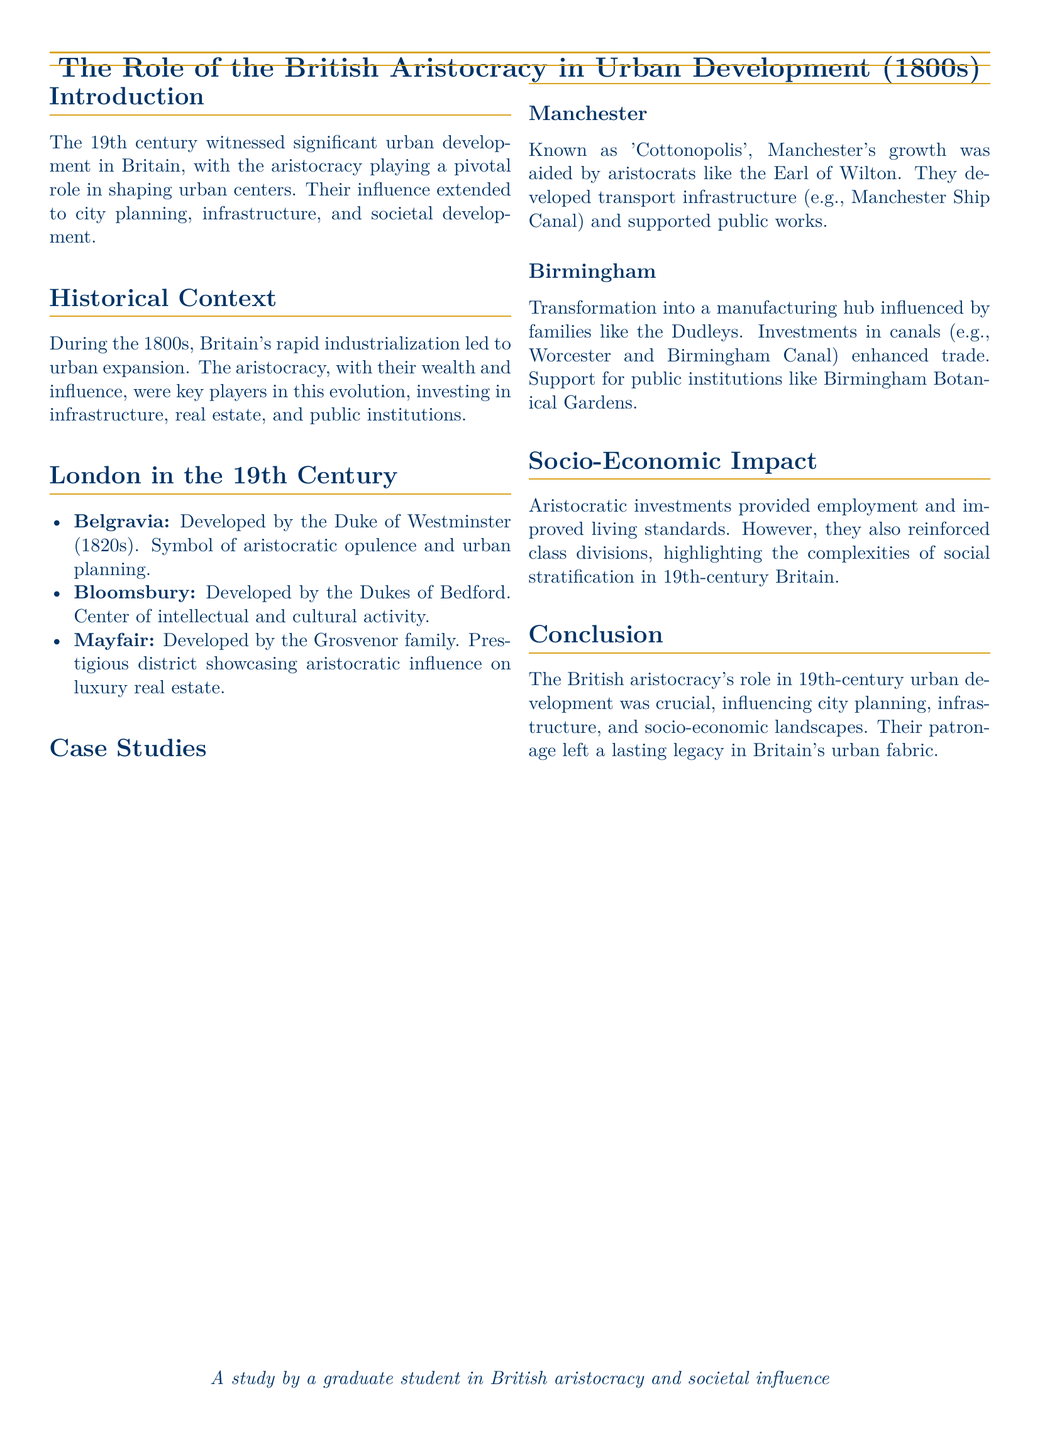what was the key player in urban development during the 1800s? The document states that the British aristocracy played a pivotal role in shaping urban centers.
Answer: British aristocracy who developed Belgravia? The Duke of Westminster developed Belgravia in the 1820s as a symbol of aristocratic opulence.
Answer: Duke of Westminster which city is referred to as 'Cottonopolis'? The document mentions Manchester as known by this nickname due to its cotton industry.
Answer: Manchester what major infrastructure did the Earl of Wilton contribute to in Manchester? The Earl of Wilton developed transport infrastructure like the Manchester Ship Canal.
Answer: Manchester Ship Canal who were the key figures in the development of Birmingham? The document highlights families like the Dudleys as influential in Birmingham's transformation.
Answer: Dudleys what type of social impact did the aristocracy's investments have? Aristocratic investments provided employment and improved living standards, but also reinforced class divisions.
Answer: Class divisions how did aristocratic investments affect socio-economic landscapes? The investments shaped urban development and class structures, reflecting complexities of social stratification.
Answer: Social stratification which family developed Mayfair? The Grosvenor family is noted for their development of Mayfair as a prestigious district.
Answer: Grosvenor family what influenced the cultural activity in Bloomsbury? The Dukes of Bedford were instrumental in developing Bloomsbury as a center of intellectual and cultural activity.
Answer: Dukes of Bedford 